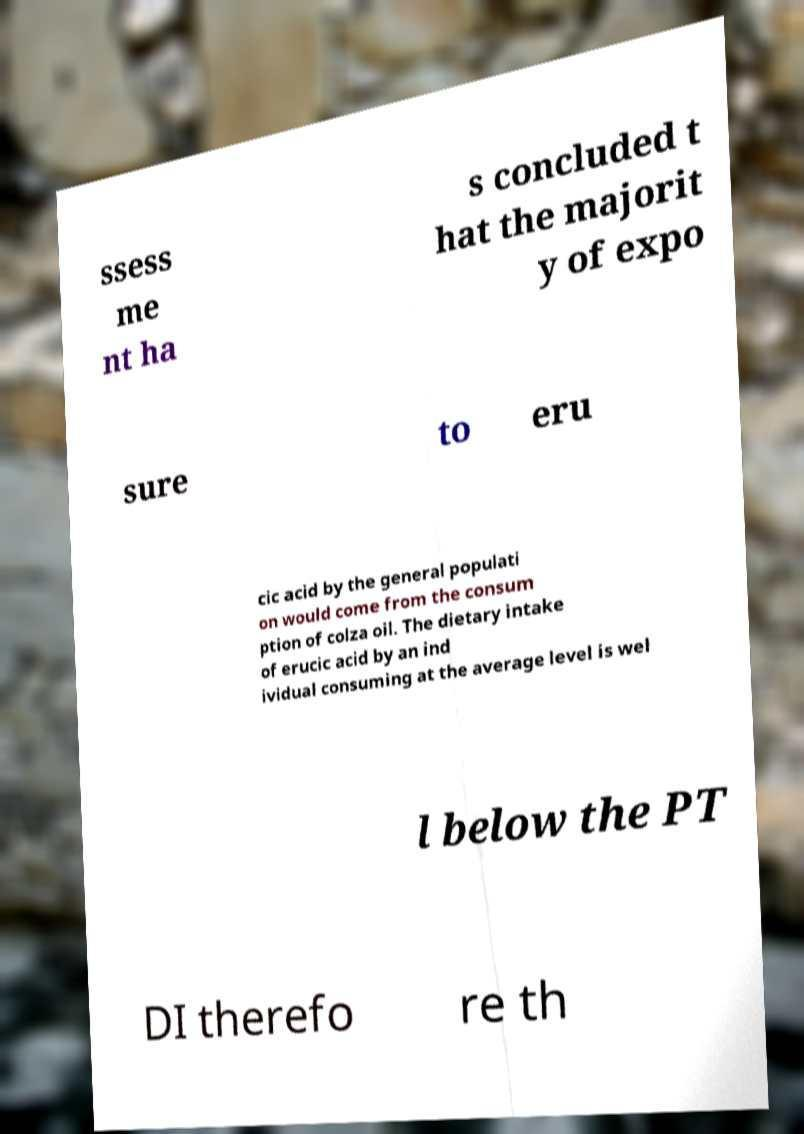Could you assist in decoding the text presented in this image and type it out clearly? ssess me nt ha s concluded t hat the majorit y of expo sure to eru cic acid by the general populati on would come from the consum ption of colza oil. The dietary intake of erucic acid by an ind ividual consuming at the average level is wel l below the PT DI therefo re th 